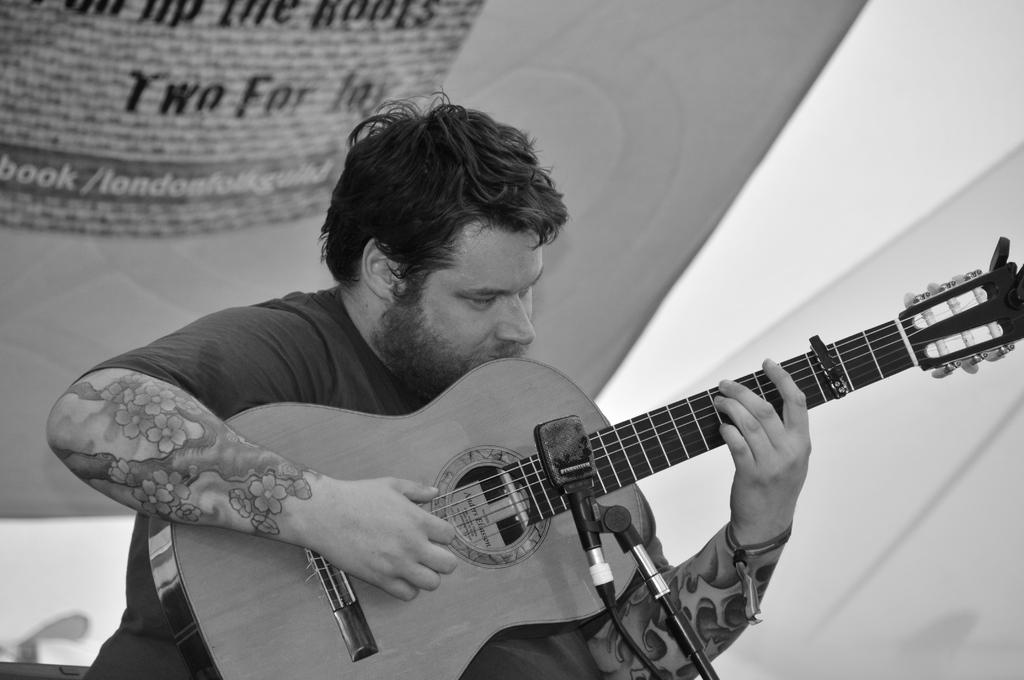What is the man in the image doing? The man is playing a guitar. How is the man positioned in the image? The man is seated. What object is in front of the man? There is a microphone in front of the man. What type of thunder can be heard in the background of the image? There is no thunder present in the image; it is a man playing a guitar with a microphone in front of him. Can you see any scissors in the image? There are no scissors visible in the image. 